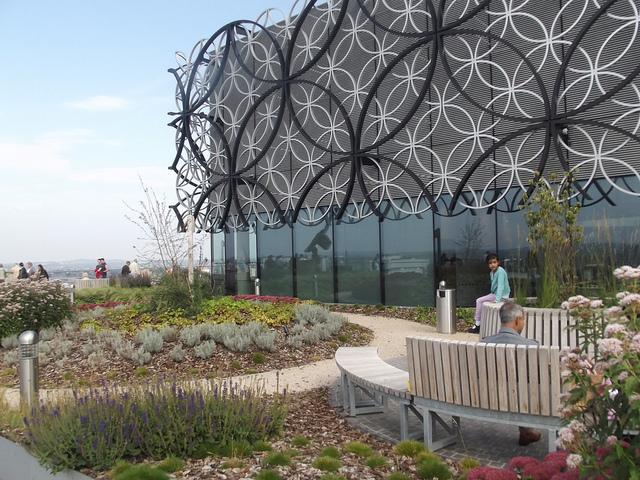What should be put in the hole near the nearby child? trash 